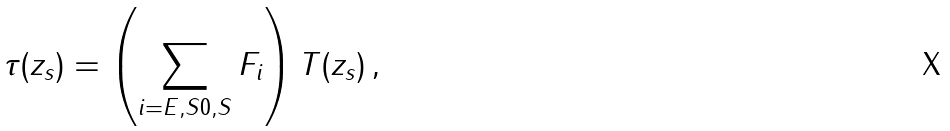<formula> <loc_0><loc_0><loc_500><loc_500>\tau ( z _ { s } ) = \left ( \sum _ { i = E , S 0 , S } F _ { i } \right ) T ( z _ { s } ) \, ,</formula> 